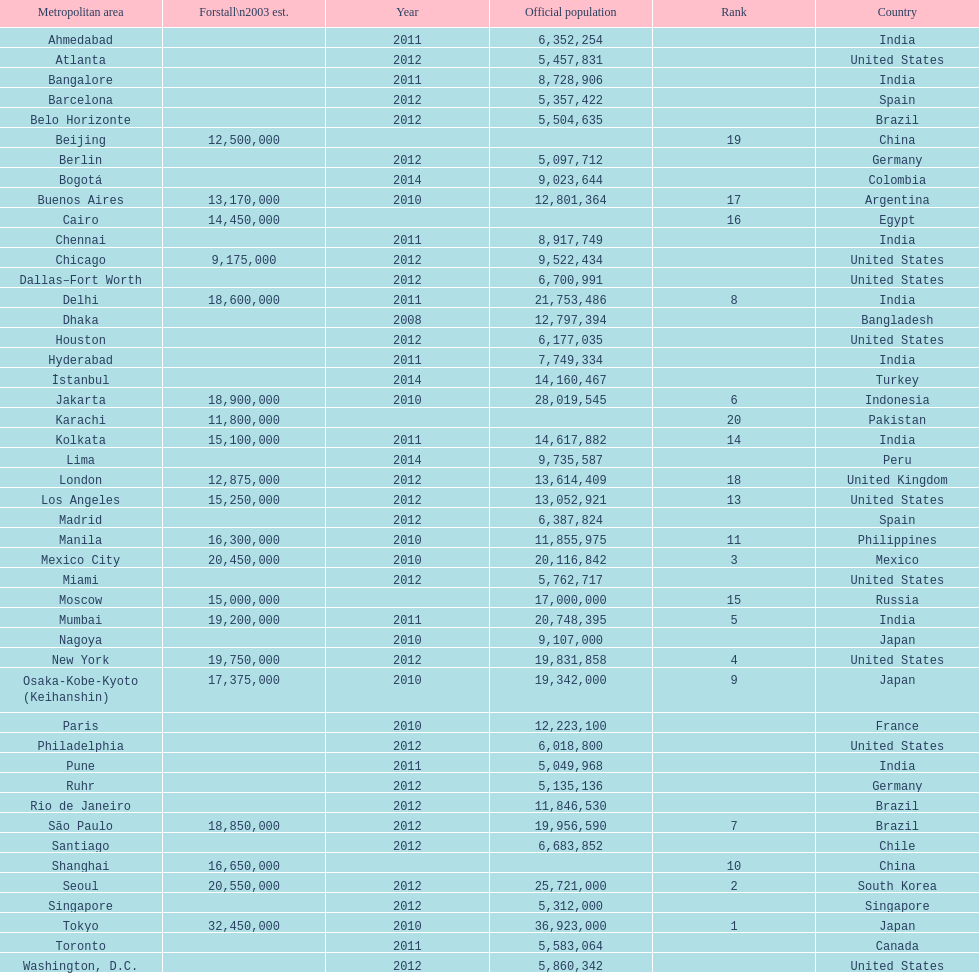What city was ranked first in 2003? Tokyo. 